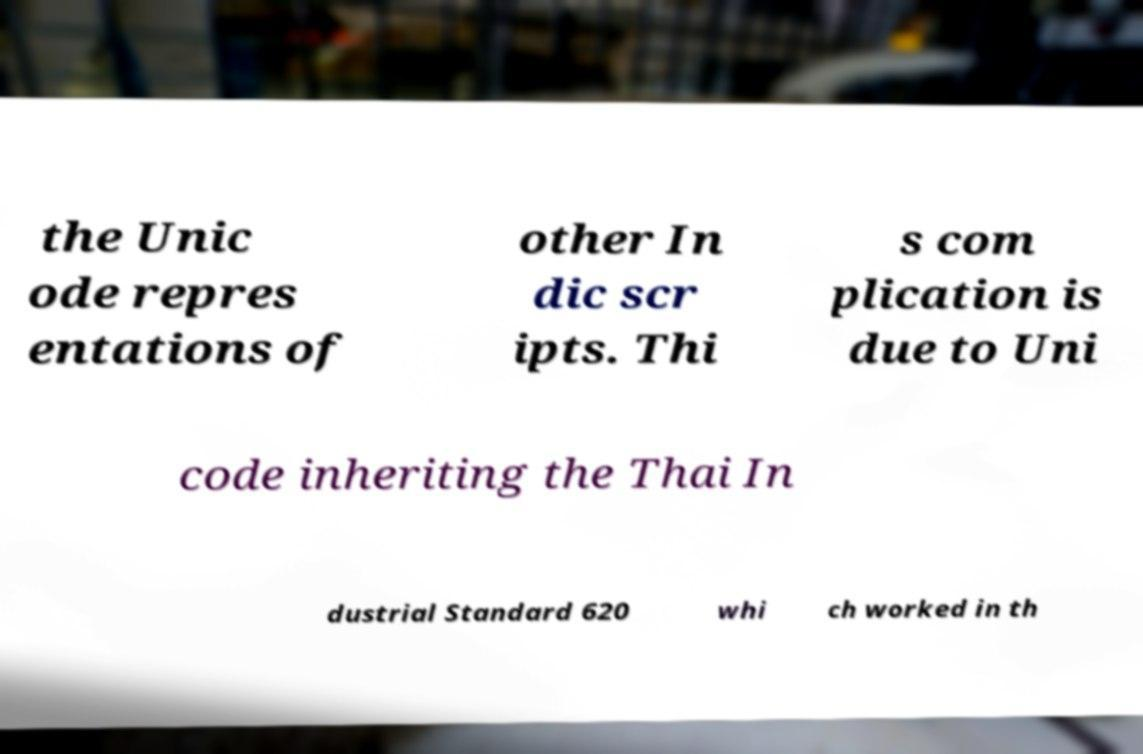Could you assist in decoding the text presented in this image and type it out clearly? the Unic ode repres entations of other In dic scr ipts. Thi s com plication is due to Uni code inheriting the Thai In dustrial Standard 620 whi ch worked in th 